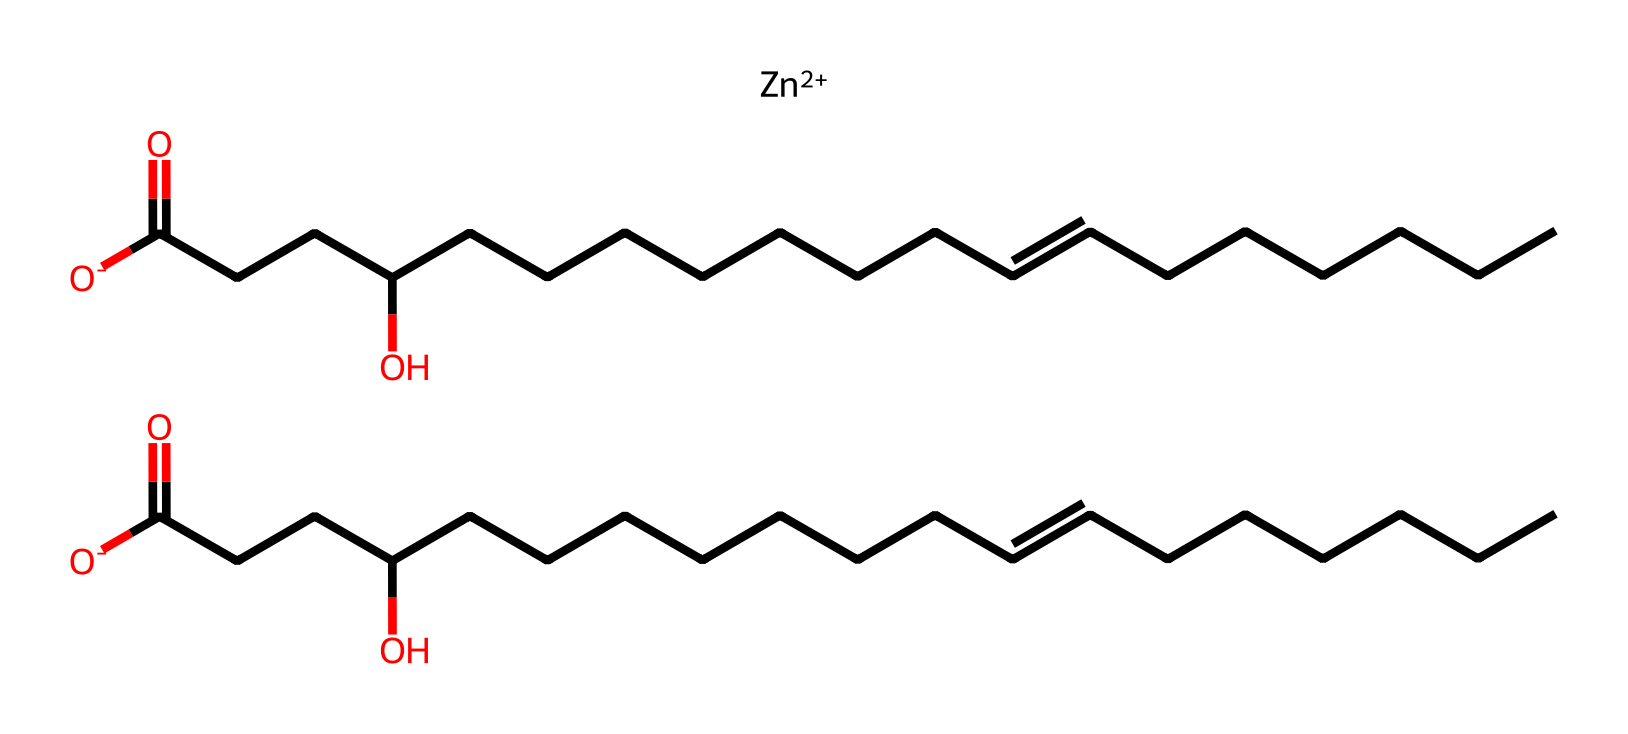What metal ion is present in this chemical structure? By examining the chemical's structure, we can identify a central metal ion bound to other components. The notation "[Zn++]" indicates that there is a zinc ion (Zn) present.
Answer: zinc How many oxygen atoms are found in this compound? The structure includes several components that are connected to oxygen. Through careful counting of the "O" symbols in the SMILES representation, we find there are three distinct oxygen atoms.
Answer: three What is the main functional group indicated in this structure? The chemical structure displays multiple carbon chains and oxygen atoms attached in a specific way. The presence of "O=C" (carbonyl) indicates that the main functional group is a carboxylic acid due to the usage of the carbonyl along with hydroxyl groups (–OH).
Answer: carboxylic acid How many carbon atoms are in the longest carbon chain within this structure? By analyzing the structure, we can locate the longest continuous sequence of carbon atoms. Counting the carbon atoms in the longest chain between the functional groups shows that there are 18 carbon atoms.
Answer: eighteen Is this compound likely to have a fruity or unpleasant smell, based on its structure? The presence of carboxylic acid groups generally contributes to strong odors. However, because it is also designed as an odor-neutralizing compound, the overall combination of functional groups and structure will likely lead to a neutral odor, suggesting it is engineered for that purpose.
Answer: unpleasant What type of application is this compound designed for? Given the context of the questions, the structure has been highlighted for its role in sports equipment, particularly for odor-neutralization, which is reflective of its design to cater to athletes’ needs.
Answer: sports equipment 